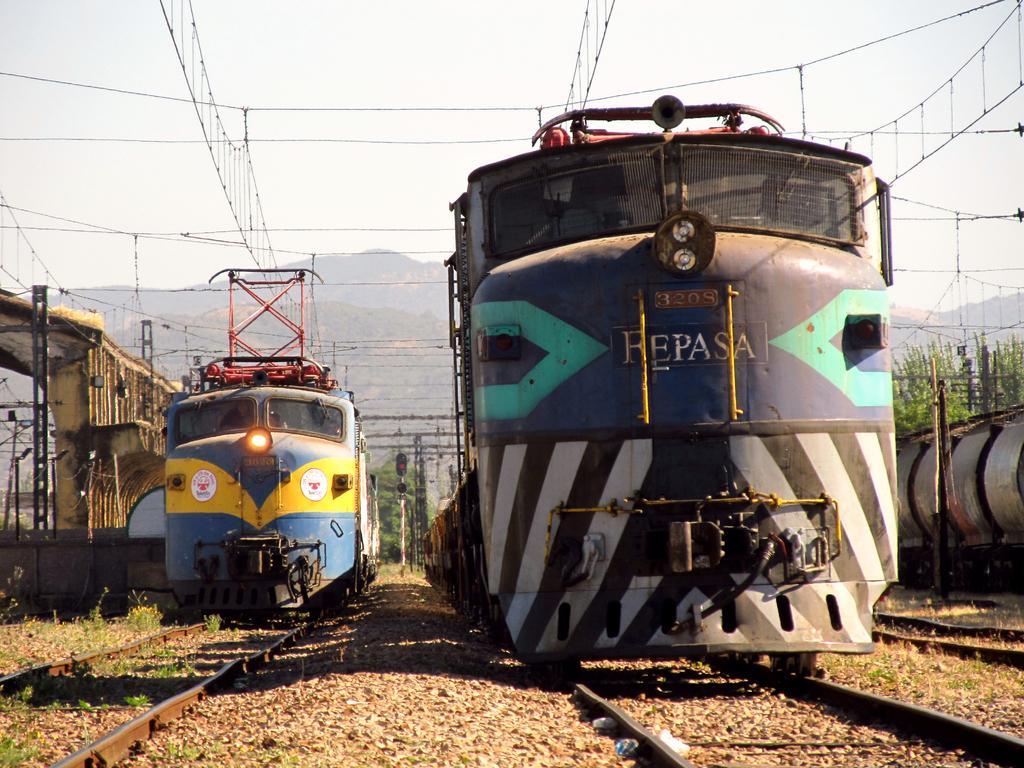Can you describe this image briefly? In the image there are few trains on the railway track and behind there are trees followed by mountains in the background and above its sky 